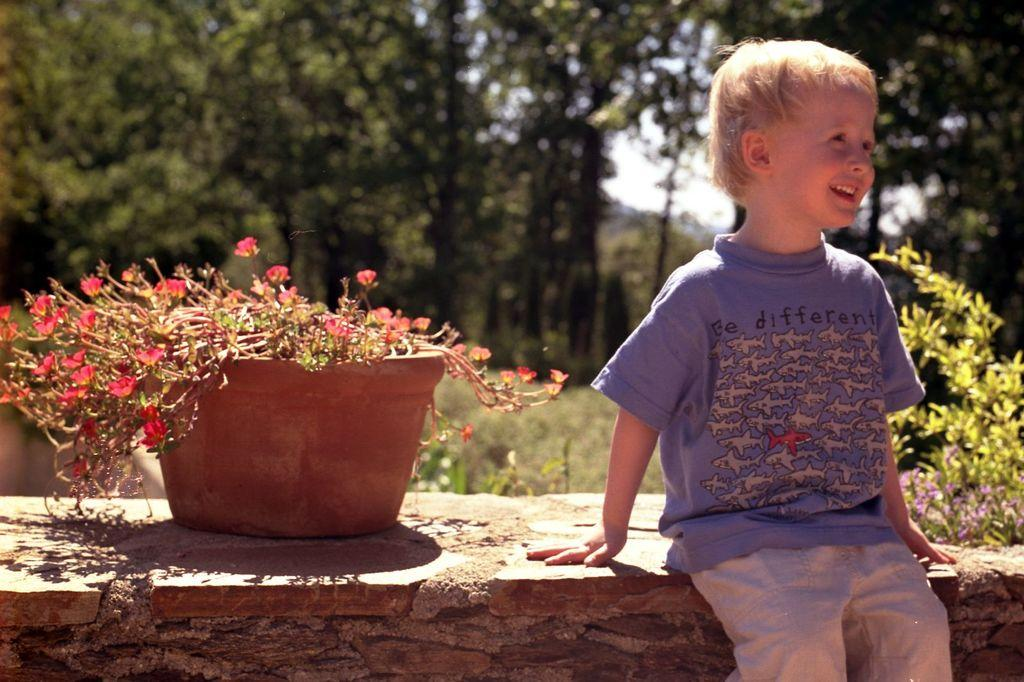What is the child doing in the image? The child is sitting on a wall in the image. What is on the wall with the child? There is a pot on the wall. What can be seen in the background of the image? There are trees in the background of the image. What type of power source is visible in the image? There is no power source visible in the image. What smell can be detected from the pot in the image? The image does not provide any information about the smell of the pot. 